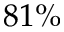<formula> <loc_0><loc_0><loc_500><loc_500>8 1 \%</formula> 